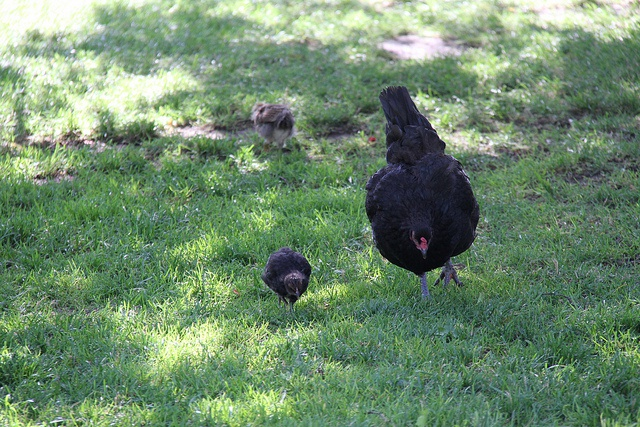Describe the objects in this image and their specific colors. I can see bird in white, black, gray, and green tones, bird in white, gray, darkgray, black, and green tones, and bird in white, black, and gray tones in this image. 